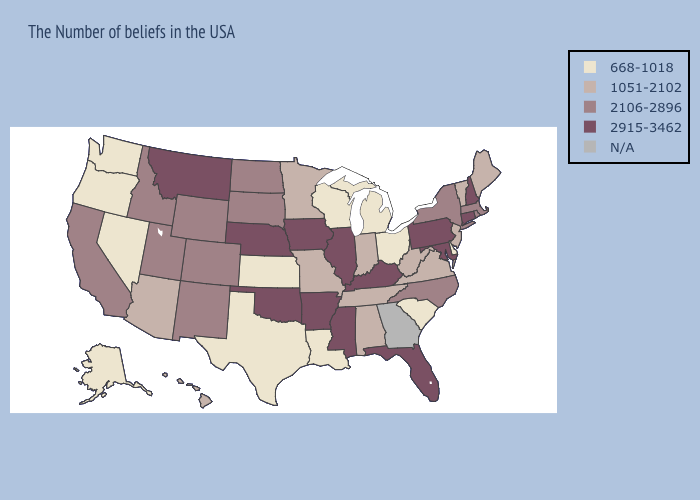What is the highest value in the South ?
Write a very short answer. 2915-3462. Does Mississippi have the highest value in the USA?
Quick response, please. Yes. Which states have the lowest value in the USA?
Answer briefly. Delaware, South Carolina, Ohio, Michigan, Wisconsin, Louisiana, Kansas, Texas, Nevada, Washington, Oregon, Alaska. What is the highest value in the USA?
Be succinct. 2915-3462. Name the states that have a value in the range 2106-2896?
Be succinct. Massachusetts, Rhode Island, New York, North Carolina, South Dakota, North Dakota, Wyoming, Colorado, New Mexico, Utah, Idaho, California. Does North Dakota have the highest value in the USA?
Answer briefly. No. What is the value of Minnesota?
Keep it brief. 1051-2102. What is the value of Kansas?
Quick response, please. 668-1018. What is the value of Wyoming?
Give a very brief answer. 2106-2896. What is the value of Illinois?
Short answer required. 2915-3462. Which states have the lowest value in the South?
Concise answer only. Delaware, South Carolina, Louisiana, Texas. Which states hav the highest value in the South?
Write a very short answer. Maryland, Florida, Kentucky, Mississippi, Arkansas, Oklahoma. What is the value of Kentucky?
Give a very brief answer. 2915-3462. What is the value of Oklahoma?
Short answer required. 2915-3462. 